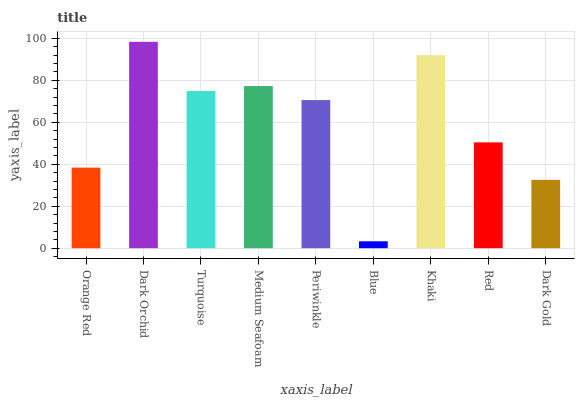Is Blue the minimum?
Answer yes or no. Yes. Is Dark Orchid the maximum?
Answer yes or no. Yes. Is Turquoise the minimum?
Answer yes or no. No. Is Turquoise the maximum?
Answer yes or no. No. Is Dark Orchid greater than Turquoise?
Answer yes or no. Yes. Is Turquoise less than Dark Orchid?
Answer yes or no. Yes. Is Turquoise greater than Dark Orchid?
Answer yes or no. No. Is Dark Orchid less than Turquoise?
Answer yes or no. No. Is Periwinkle the high median?
Answer yes or no. Yes. Is Periwinkle the low median?
Answer yes or no. Yes. Is Turquoise the high median?
Answer yes or no. No. Is Dark Gold the low median?
Answer yes or no. No. 